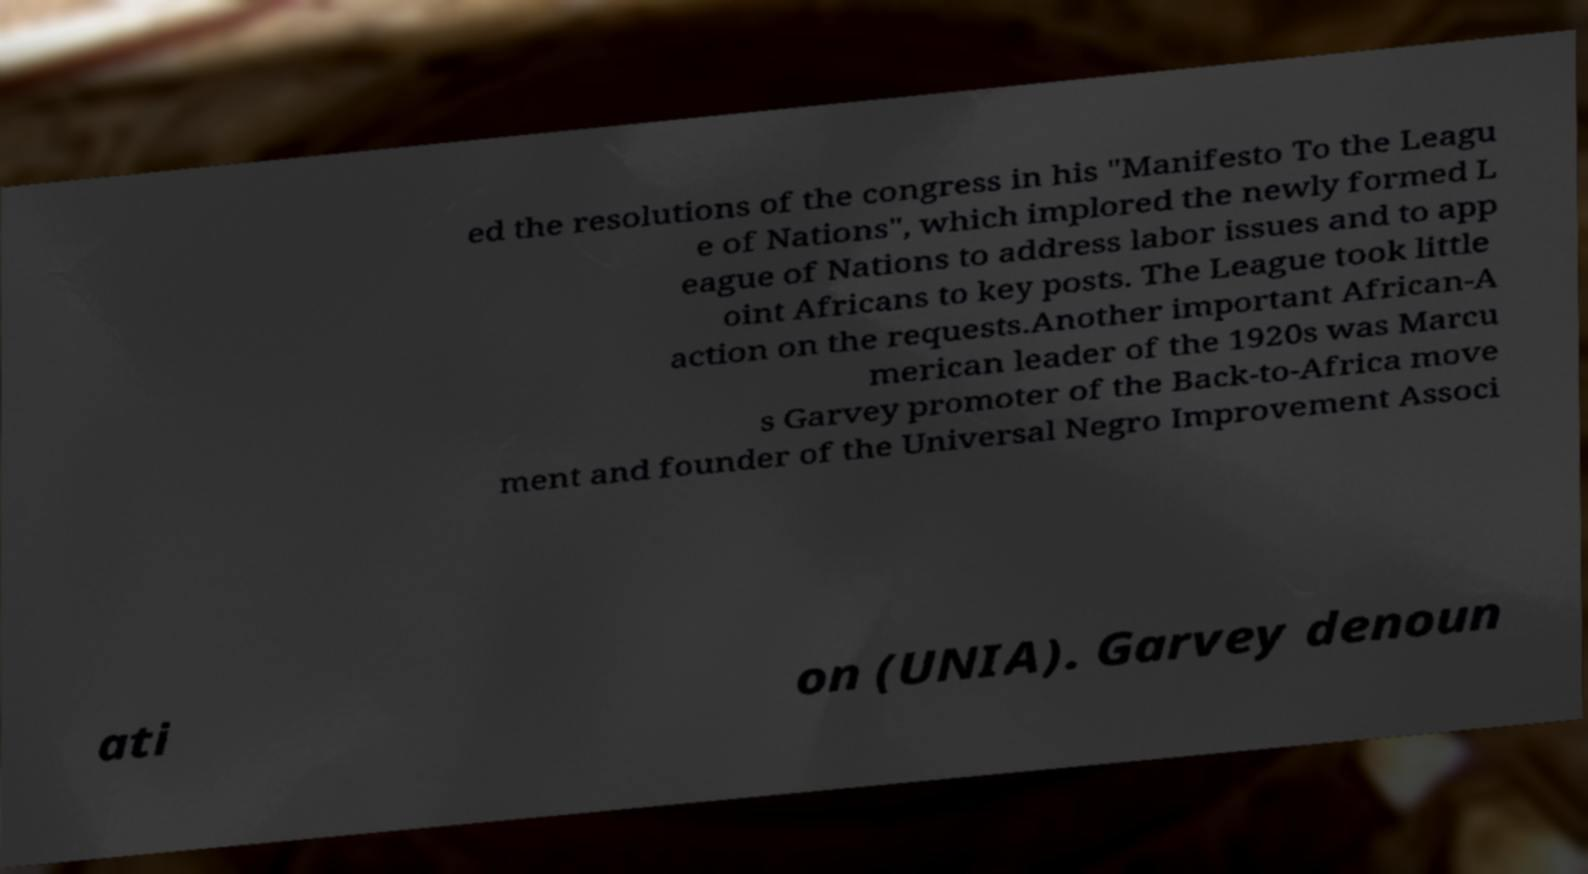Please identify and transcribe the text found in this image. ed the resolutions of the congress in his "Manifesto To the Leagu e of Nations", which implored the newly formed L eague of Nations to address labor issues and to app oint Africans to key posts. The League took little action on the requests.Another important African-A merican leader of the 1920s was Marcu s Garvey promoter of the Back-to-Africa move ment and founder of the Universal Negro Improvement Associ ati on (UNIA). Garvey denoun 